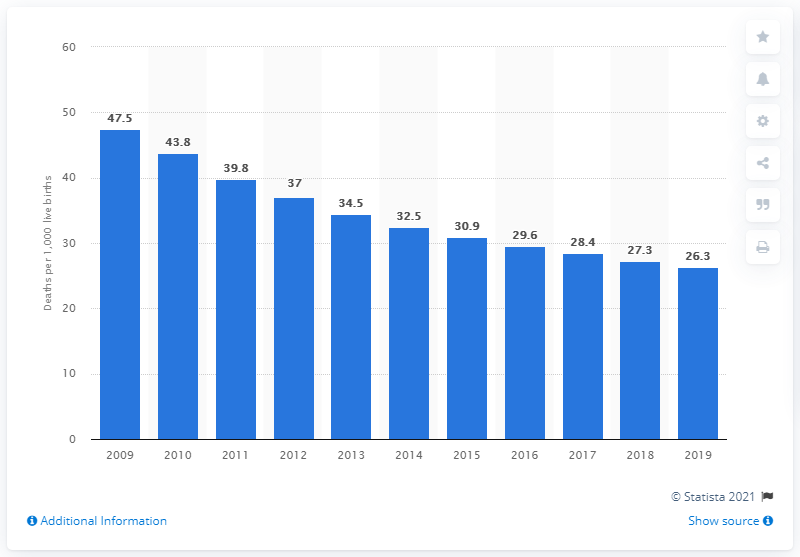Identify some key points in this picture. The infant mortality rate in Rwanda in 2019 was 26.3 deaths per 1,000 live births, according to recent data. 